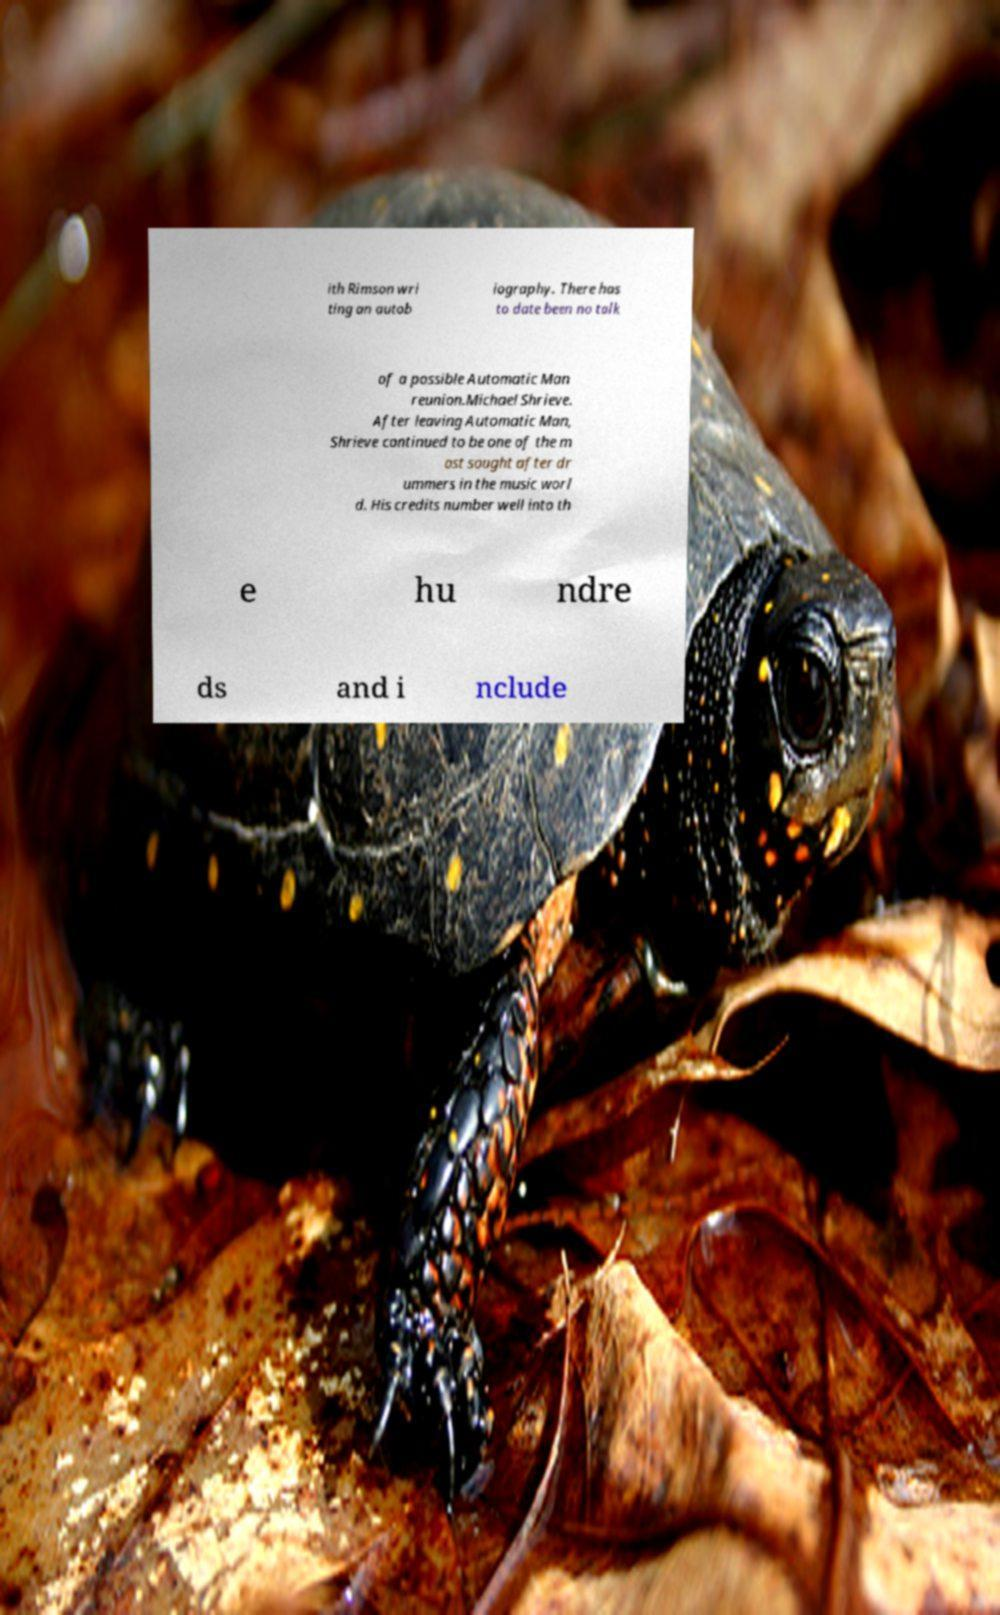There's text embedded in this image that I need extracted. Can you transcribe it verbatim? ith Rimson wri ting an autob iography. There has to date been no talk of a possible Automatic Man reunion.Michael Shrieve. After leaving Automatic Man, Shrieve continued to be one of the m ost sought after dr ummers in the music worl d. His credits number well into th e hu ndre ds and i nclude 